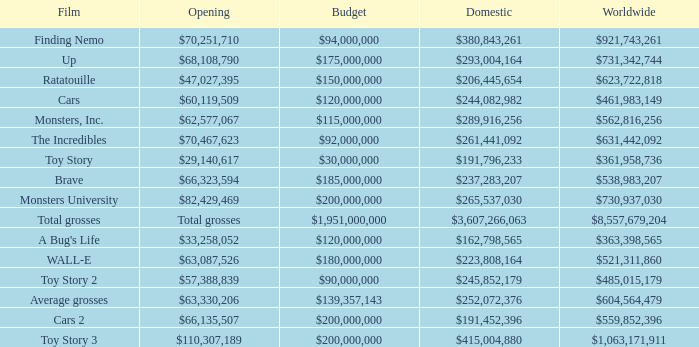WHAT IS THE BUDGET FOR THE INCREDIBLES? $92,000,000. 